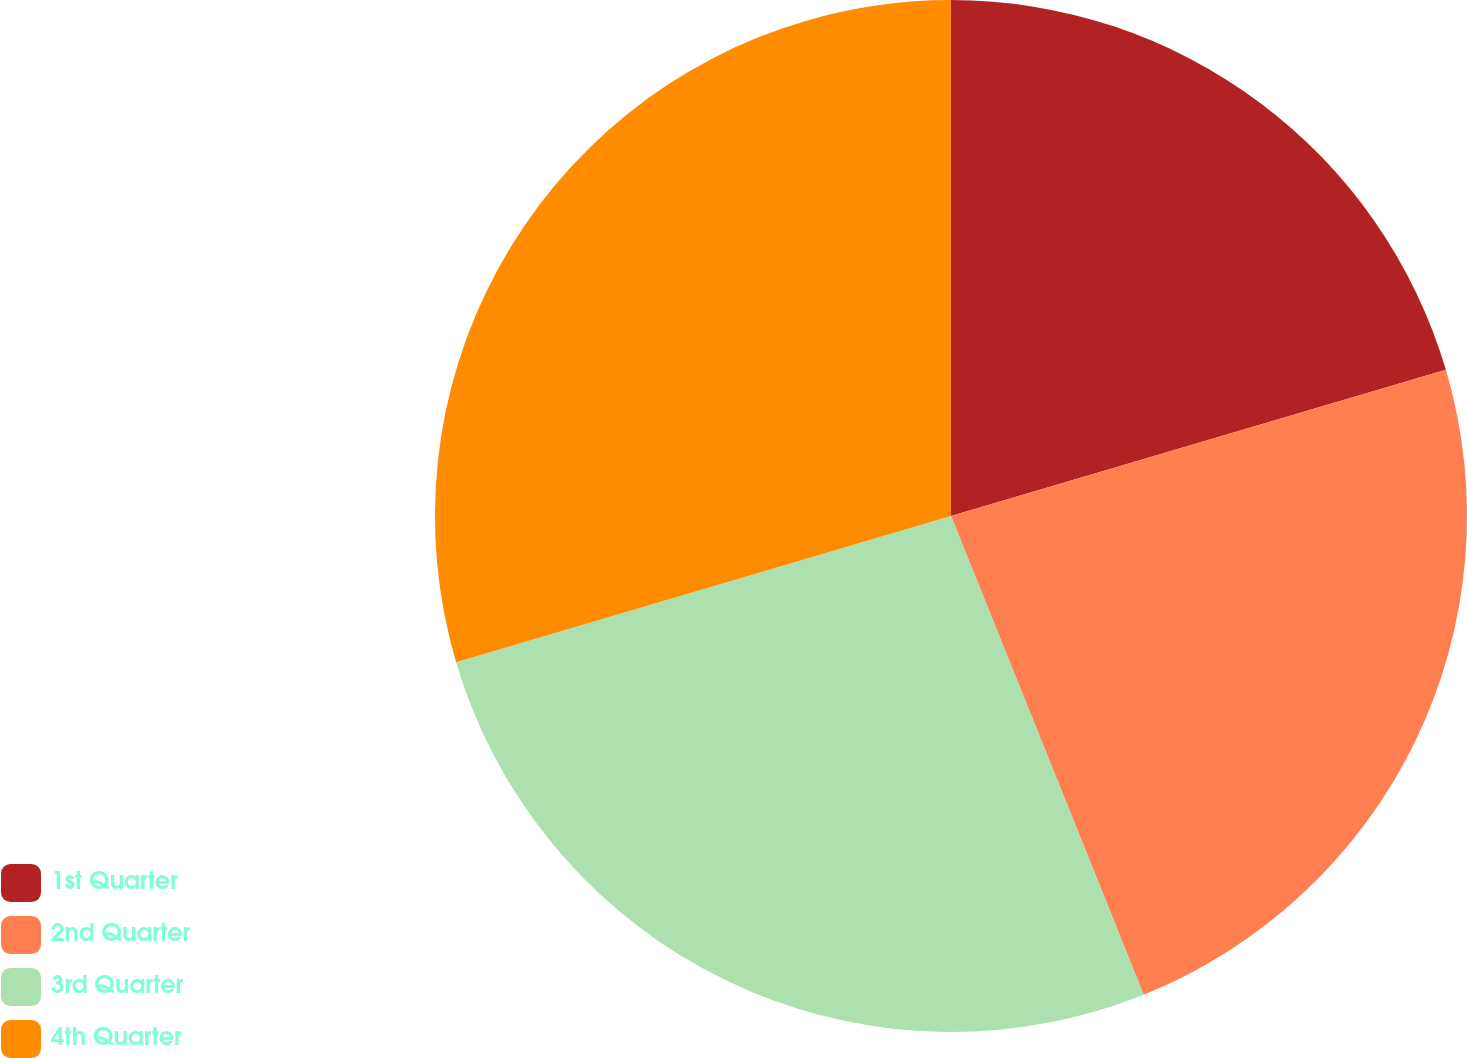<chart> <loc_0><loc_0><loc_500><loc_500><pie_chart><fcel>1st Quarter<fcel>2nd Quarter<fcel>3rd Quarter<fcel>4th Quarter<nl><fcel>20.43%<fcel>23.48%<fcel>26.52%<fcel>29.57%<nl></chart> 